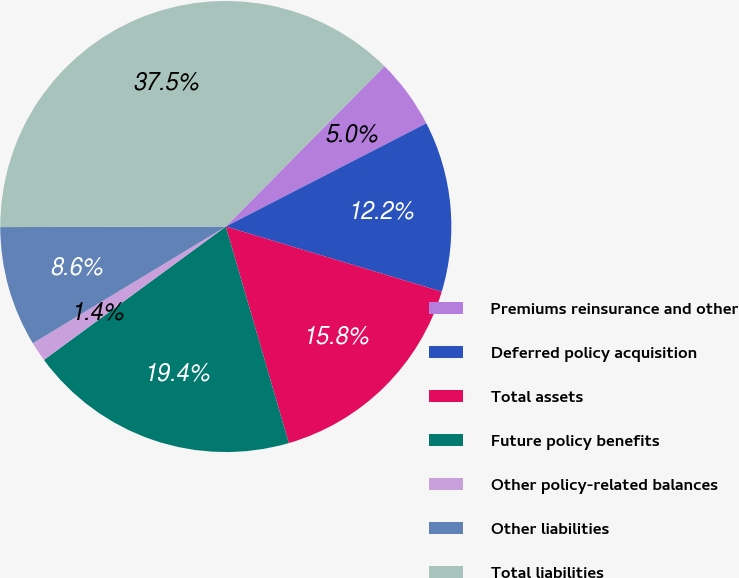Convert chart to OTSL. <chart><loc_0><loc_0><loc_500><loc_500><pie_chart><fcel>Premiums reinsurance and other<fcel>Deferred policy acquisition<fcel>Total assets<fcel>Future policy benefits<fcel>Other policy-related balances<fcel>Other liabilities<fcel>Total liabilities<nl><fcel>5.02%<fcel>12.23%<fcel>15.83%<fcel>19.44%<fcel>1.41%<fcel>8.62%<fcel>37.46%<nl></chart> 